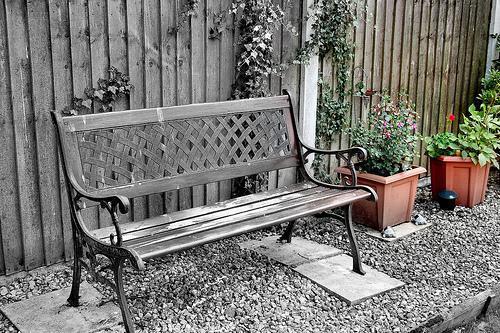How many planters are there?
Give a very brief answer. 2. How many of the plants are in color?
Give a very brief answer. 3. 